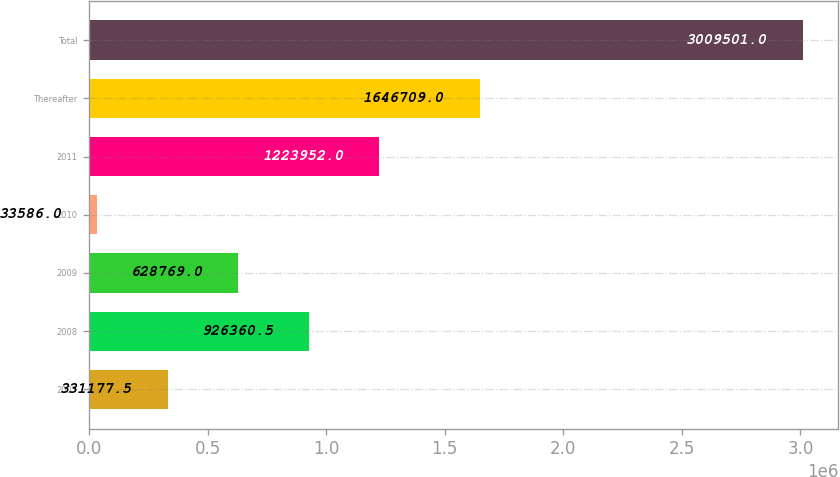<chart> <loc_0><loc_0><loc_500><loc_500><bar_chart><fcel>2007<fcel>2008<fcel>2009<fcel>2010<fcel>2011<fcel>Thereafter<fcel>Total<nl><fcel>331178<fcel>926360<fcel>628769<fcel>33586<fcel>1.22395e+06<fcel>1.64671e+06<fcel>3.0095e+06<nl></chart> 